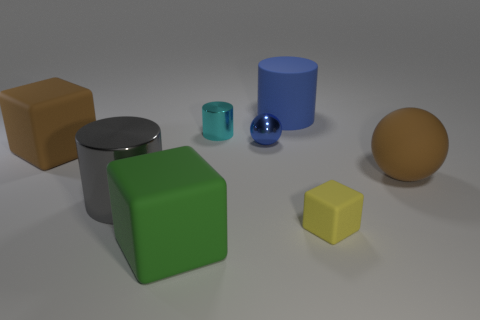Subtract all green cylinders. Subtract all green cubes. How many cylinders are left? 3 Subtract all cyan cubes. How many red balls are left? 0 Add 1 small greens. How many tiny yellows exist? 0 Subtract all big metal spheres. Subtract all brown things. How many objects are left? 6 Add 5 big balls. How many big balls are left? 6 Add 6 rubber cylinders. How many rubber cylinders exist? 7 Add 1 cylinders. How many objects exist? 9 Subtract all cyan cylinders. How many cylinders are left? 2 Subtract all cyan cylinders. How many cylinders are left? 2 Subtract 1 cyan cylinders. How many objects are left? 7 